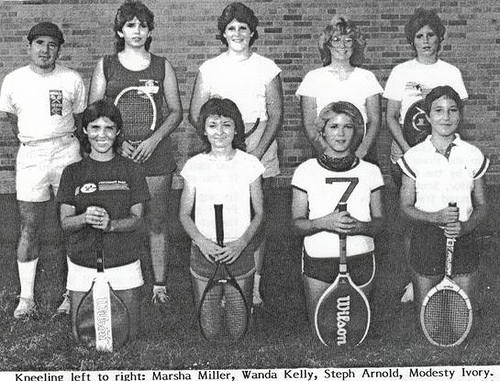Identify the text displayed in this image. left to Marsha Miller Ivory. Modesty Arnold, STEPH Kelly, Wanda Wilson 7 